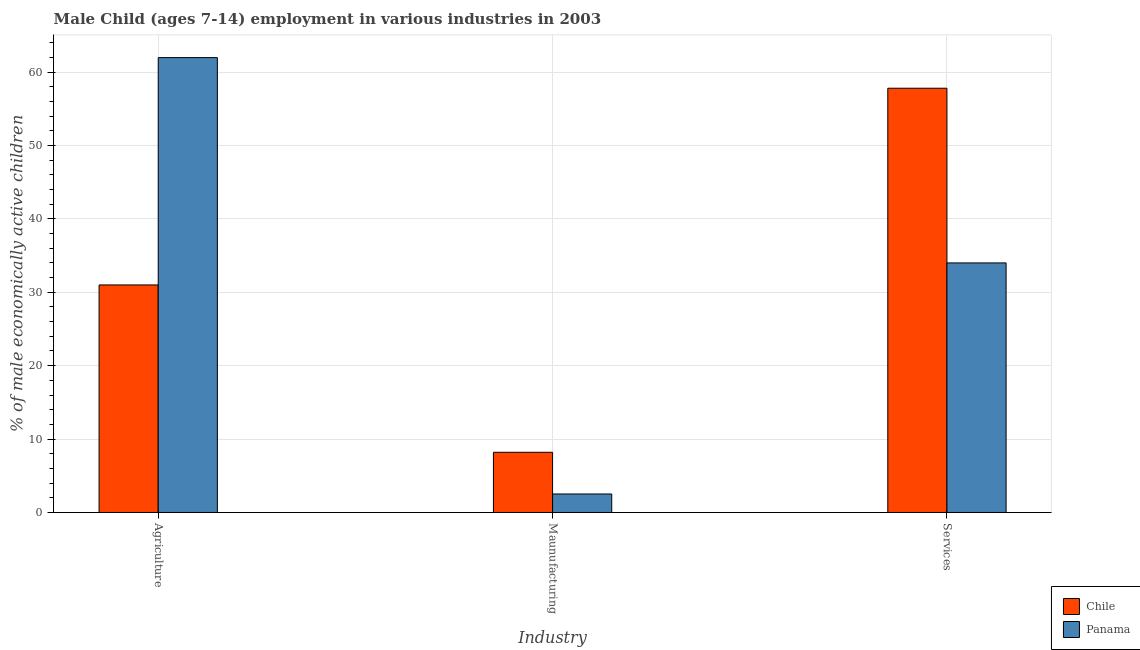Are the number of bars on each tick of the X-axis equal?
Make the answer very short. Yes. How many bars are there on the 2nd tick from the left?
Offer a very short reply. 2. What is the label of the 1st group of bars from the left?
Offer a terse response. Agriculture. What is the percentage of economically active children in agriculture in Panama?
Provide a succinct answer. 61.97. Across all countries, what is the maximum percentage of economically active children in services?
Provide a succinct answer. 57.8. Across all countries, what is the minimum percentage of economically active children in manufacturing?
Offer a terse response. 2.52. In which country was the percentage of economically active children in agriculture maximum?
Make the answer very short. Panama. In which country was the percentage of economically active children in manufacturing minimum?
Offer a very short reply. Panama. What is the total percentage of economically active children in agriculture in the graph?
Offer a terse response. 92.97. What is the difference between the percentage of economically active children in agriculture in Chile and that in Panama?
Offer a terse response. -30.97. What is the difference between the percentage of economically active children in agriculture in Chile and the percentage of economically active children in services in Panama?
Ensure brevity in your answer.  -3. What is the average percentage of economically active children in agriculture per country?
Offer a very short reply. 46.48. What is the difference between the percentage of economically active children in manufacturing and percentage of economically active children in services in Chile?
Offer a terse response. -49.6. In how many countries, is the percentage of economically active children in services greater than 36 %?
Make the answer very short. 1. What is the ratio of the percentage of economically active children in agriculture in Panama to that in Chile?
Make the answer very short. 2. Is the percentage of economically active children in services in Chile less than that in Panama?
Offer a very short reply. No. Is the difference between the percentage of economically active children in manufacturing in Chile and Panama greater than the difference between the percentage of economically active children in services in Chile and Panama?
Your response must be concise. No. What is the difference between the highest and the second highest percentage of economically active children in services?
Ensure brevity in your answer.  23.8. What is the difference between the highest and the lowest percentage of economically active children in agriculture?
Your answer should be very brief. 30.97. Is it the case that in every country, the sum of the percentage of economically active children in agriculture and percentage of economically active children in manufacturing is greater than the percentage of economically active children in services?
Provide a short and direct response. No. Are all the bars in the graph horizontal?
Provide a short and direct response. No. How many countries are there in the graph?
Provide a short and direct response. 2. Are the values on the major ticks of Y-axis written in scientific E-notation?
Your answer should be very brief. No. Does the graph contain any zero values?
Your response must be concise. No. Does the graph contain grids?
Your answer should be compact. Yes. Where does the legend appear in the graph?
Offer a terse response. Bottom right. What is the title of the graph?
Make the answer very short. Male Child (ages 7-14) employment in various industries in 2003. Does "Gabon" appear as one of the legend labels in the graph?
Provide a short and direct response. No. What is the label or title of the X-axis?
Your response must be concise. Industry. What is the label or title of the Y-axis?
Provide a short and direct response. % of male economically active children. What is the % of male economically active children in Panama in Agriculture?
Your answer should be very brief. 61.97. What is the % of male economically active children of Chile in Maunufacturing?
Ensure brevity in your answer.  8.2. What is the % of male economically active children of Panama in Maunufacturing?
Offer a terse response. 2.52. What is the % of male economically active children of Chile in Services?
Ensure brevity in your answer.  57.8. Across all Industry, what is the maximum % of male economically active children in Chile?
Give a very brief answer. 57.8. Across all Industry, what is the maximum % of male economically active children in Panama?
Make the answer very short. 61.97. Across all Industry, what is the minimum % of male economically active children of Panama?
Ensure brevity in your answer.  2.52. What is the total % of male economically active children in Chile in the graph?
Provide a succinct answer. 97. What is the total % of male economically active children in Panama in the graph?
Your answer should be very brief. 98.49. What is the difference between the % of male economically active children in Chile in Agriculture and that in Maunufacturing?
Your answer should be very brief. 22.8. What is the difference between the % of male economically active children in Panama in Agriculture and that in Maunufacturing?
Your answer should be compact. 59.45. What is the difference between the % of male economically active children of Chile in Agriculture and that in Services?
Ensure brevity in your answer.  -26.8. What is the difference between the % of male economically active children of Panama in Agriculture and that in Services?
Ensure brevity in your answer.  27.97. What is the difference between the % of male economically active children in Chile in Maunufacturing and that in Services?
Your answer should be very brief. -49.6. What is the difference between the % of male economically active children of Panama in Maunufacturing and that in Services?
Give a very brief answer. -31.48. What is the difference between the % of male economically active children in Chile in Agriculture and the % of male economically active children in Panama in Maunufacturing?
Offer a very short reply. 28.48. What is the difference between the % of male economically active children in Chile in Maunufacturing and the % of male economically active children in Panama in Services?
Your response must be concise. -25.8. What is the average % of male economically active children of Chile per Industry?
Keep it short and to the point. 32.33. What is the average % of male economically active children in Panama per Industry?
Your response must be concise. 32.83. What is the difference between the % of male economically active children in Chile and % of male economically active children in Panama in Agriculture?
Keep it short and to the point. -30.97. What is the difference between the % of male economically active children of Chile and % of male economically active children of Panama in Maunufacturing?
Your response must be concise. 5.68. What is the difference between the % of male economically active children of Chile and % of male economically active children of Panama in Services?
Your response must be concise. 23.8. What is the ratio of the % of male economically active children of Chile in Agriculture to that in Maunufacturing?
Give a very brief answer. 3.78. What is the ratio of the % of male economically active children in Panama in Agriculture to that in Maunufacturing?
Offer a terse response. 24.59. What is the ratio of the % of male economically active children of Chile in Agriculture to that in Services?
Give a very brief answer. 0.54. What is the ratio of the % of male economically active children in Panama in Agriculture to that in Services?
Give a very brief answer. 1.82. What is the ratio of the % of male economically active children of Chile in Maunufacturing to that in Services?
Your response must be concise. 0.14. What is the ratio of the % of male economically active children of Panama in Maunufacturing to that in Services?
Keep it short and to the point. 0.07. What is the difference between the highest and the second highest % of male economically active children of Chile?
Offer a terse response. 26.8. What is the difference between the highest and the second highest % of male economically active children in Panama?
Keep it short and to the point. 27.97. What is the difference between the highest and the lowest % of male economically active children of Chile?
Your answer should be very brief. 49.6. What is the difference between the highest and the lowest % of male economically active children in Panama?
Offer a very short reply. 59.45. 